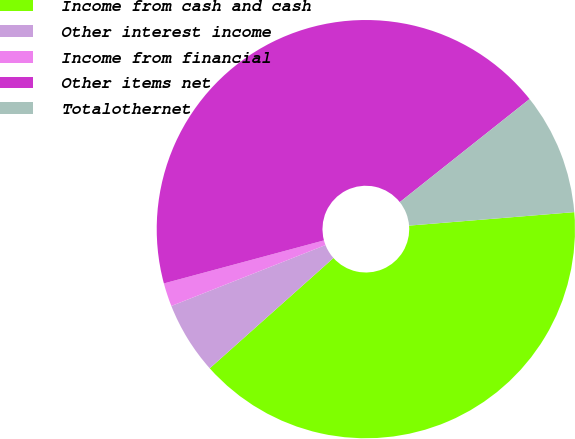Convert chart to OTSL. <chart><loc_0><loc_0><loc_500><loc_500><pie_chart><fcel>Income from cash and cash<fcel>Other interest income<fcel>Income from financial<fcel>Other items net<fcel>Totalothernet<nl><fcel>39.71%<fcel>5.6%<fcel>1.81%<fcel>43.5%<fcel>9.39%<nl></chart> 